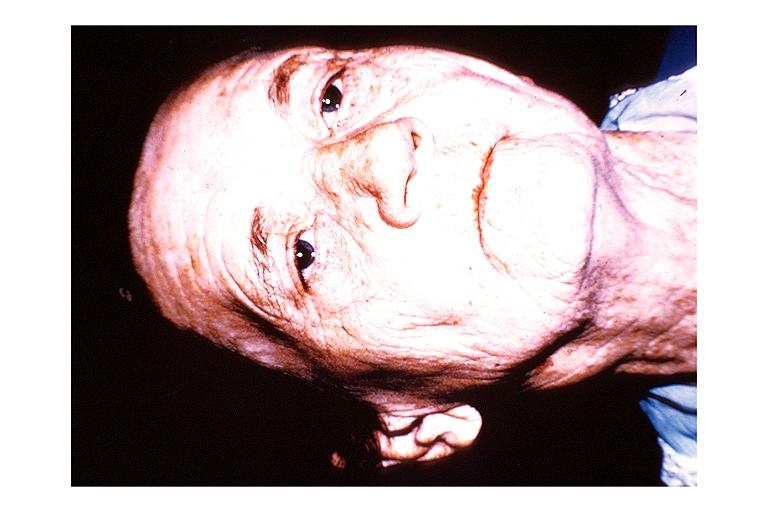does this image show papillary cystadenoma lymphomatosum warthins?
Answer the question using a single word or phrase. Yes 